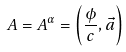<formula> <loc_0><loc_0><loc_500><loc_500>A = A ^ { \alpha } = \left ( { \frac { \phi } { c } } , \vec { a } \right )</formula> 